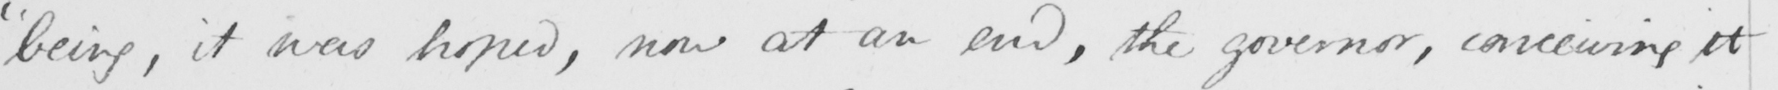Transcribe the text shown in this historical manuscript line. " being , it was hoped , now at an end , the governor , conceiving it 